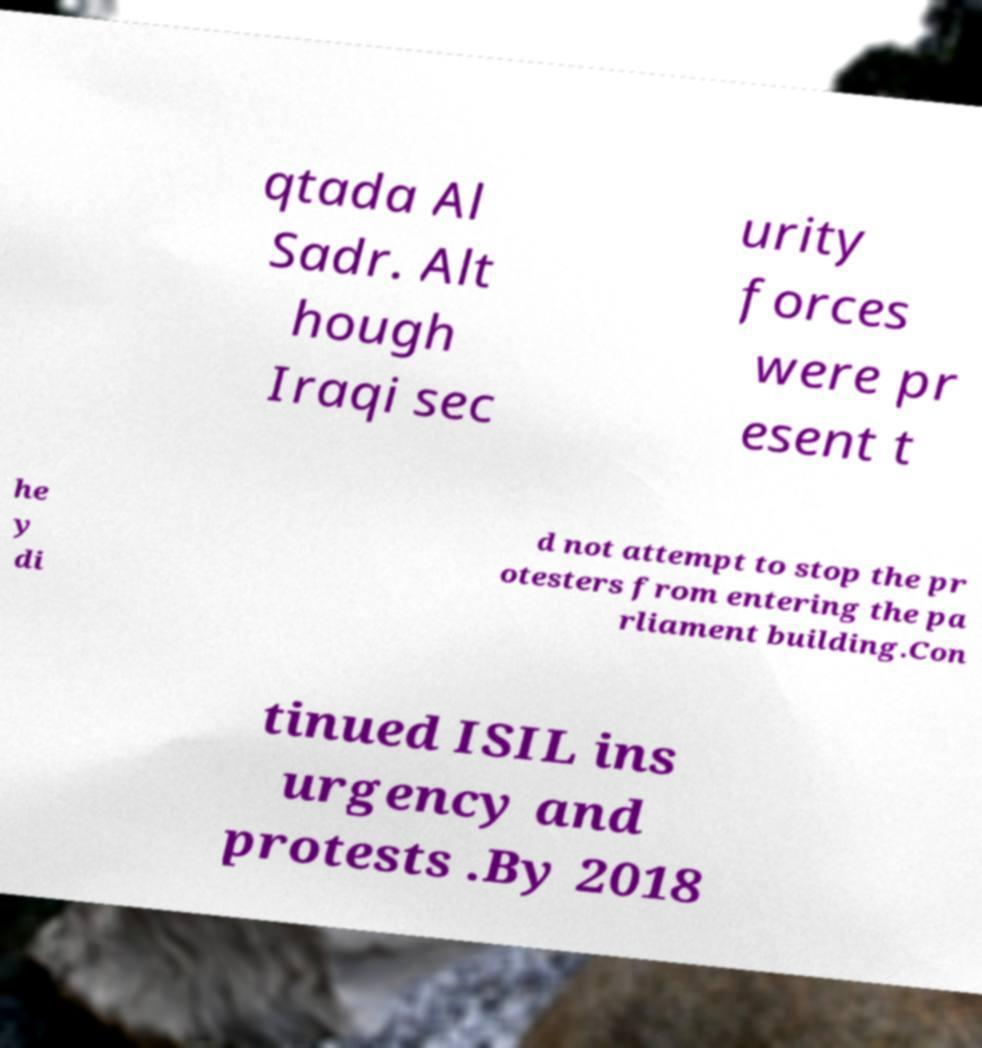Could you extract and type out the text from this image? qtada Al Sadr. Alt hough Iraqi sec urity forces were pr esent t he y di d not attempt to stop the pr otesters from entering the pa rliament building.Con tinued ISIL ins urgency and protests .By 2018 